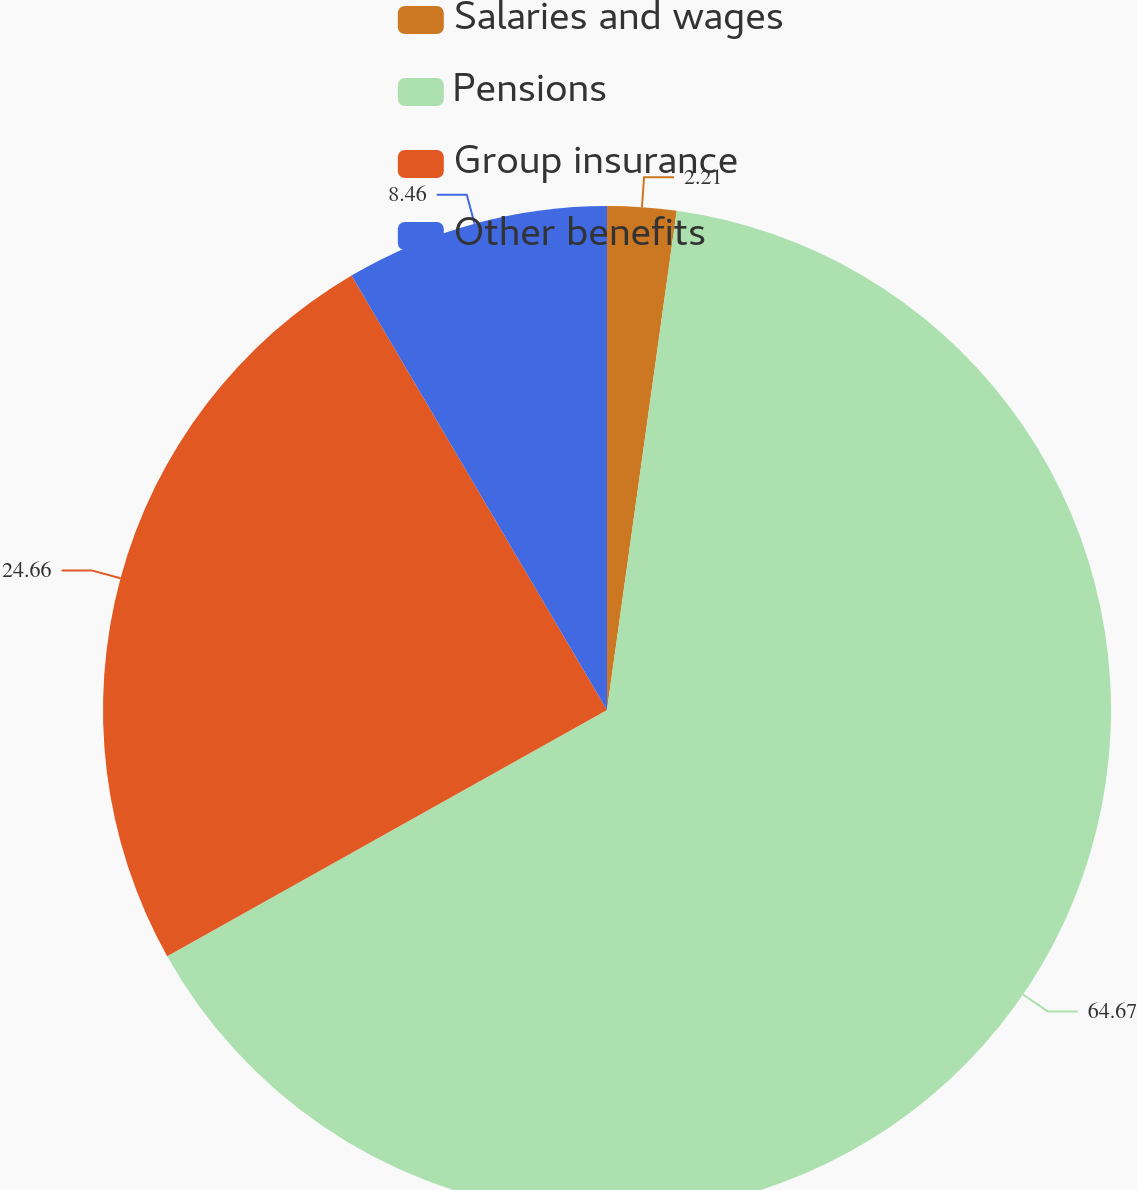Convert chart. <chart><loc_0><loc_0><loc_500><loc_500><pie_chart><fcel>Salaries and wages<fcel>Pensions<fcel>Group insurance<fcel>Other benefits<nl><fcel>2.21%<fcel>64.67%<fcel>24.66%<fcel>8.46%<nl></chart> 